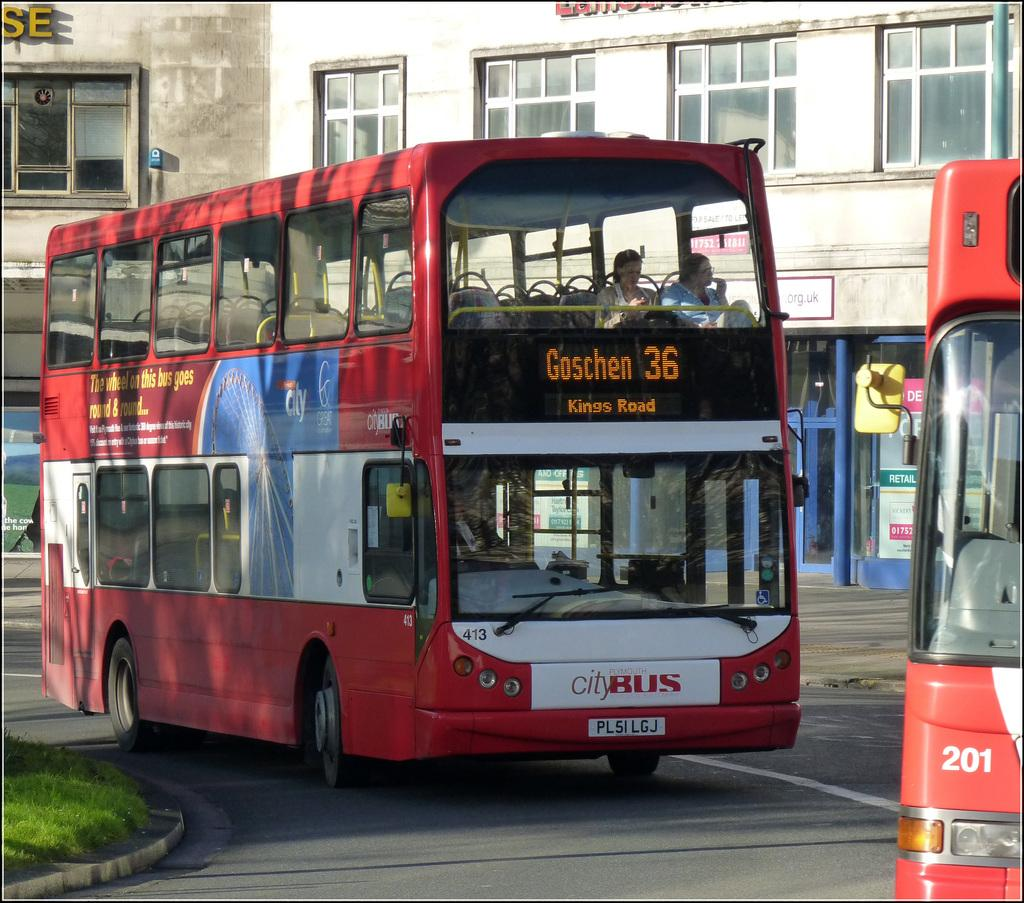<image>
Provide a brief description of the given image. A number 36 bus drives down a road. 